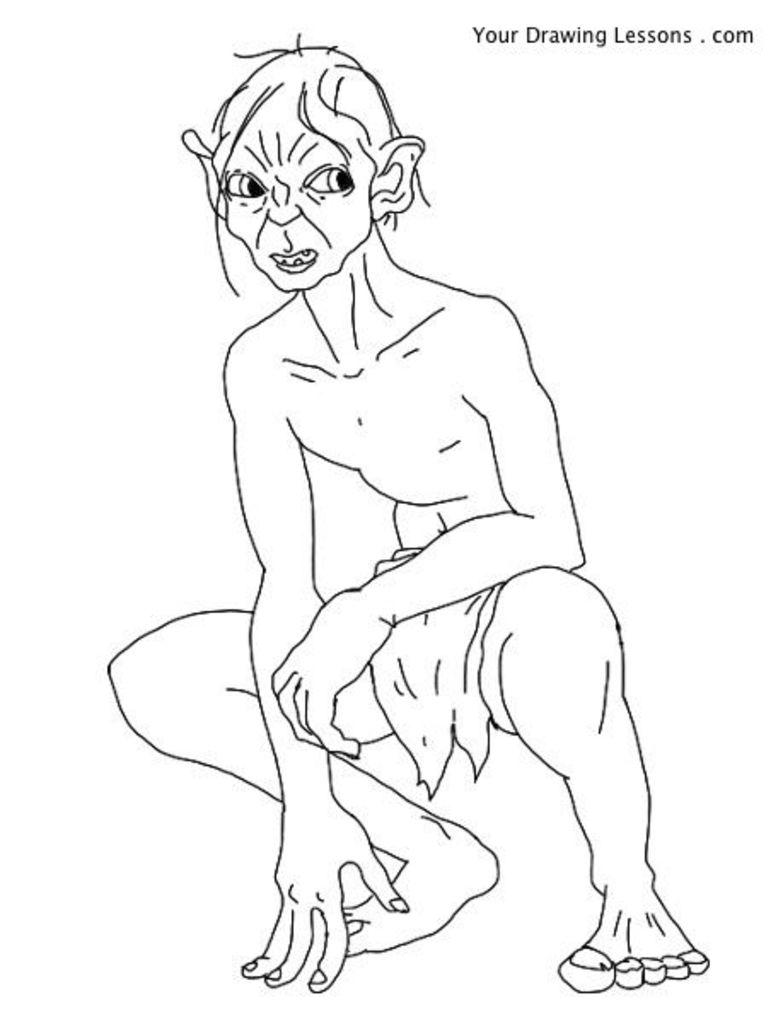What is the main subject of the image? The main subject of the image is a drawing of a person. What color is the background of the image? The background of the image is white. How many chairs are depicted in the drawing of the person? There are no chairs depicted in the drawing of the person, as the image only features a person and a white background. What type of rock is visible in the drawing of the person? There is no rock present in the drawing of the person; it only features a person and a white background. 